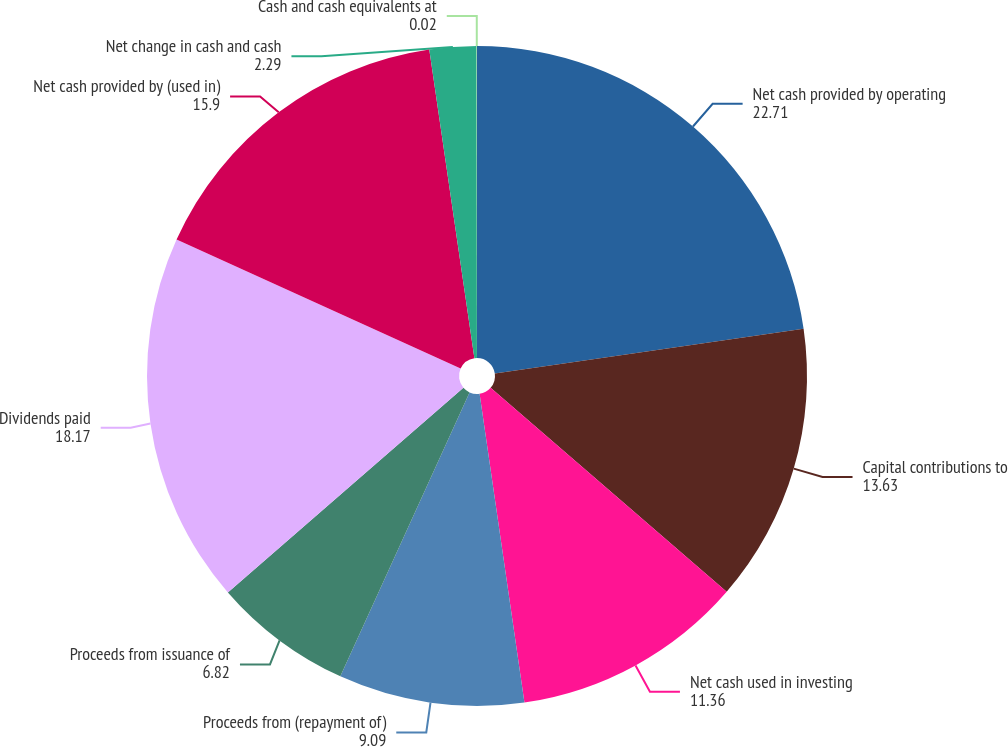Convert chart. <chart><loc_0><loc_0><loc_500><loc_500><pie_chart><fcel>Net cash provided by operating<fcel>Capital contributions to<fcel>Net cash used in investing<fcel>Proceeds from (repayment of)<fcel>Proceeds from issuance of<fcel>Dividends paid<fcel>Net cash provided by (used in)<fcel>Net change in cash and cash<fcel>Cash and cash equivalents at<nl><fcel>22.71%<fcel>13.63%<fcel>11.36%<fcel>9.09%<fcel>6.82%<fcel>18.17%<fcel>15.9%<fcel>2.29%<fcel>0.02%<nl></chart> 